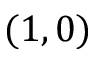Convert formula to latex. <formula><loc_0><loc_0><loc_500><loc_500>( 1 , 0 )</formula> 